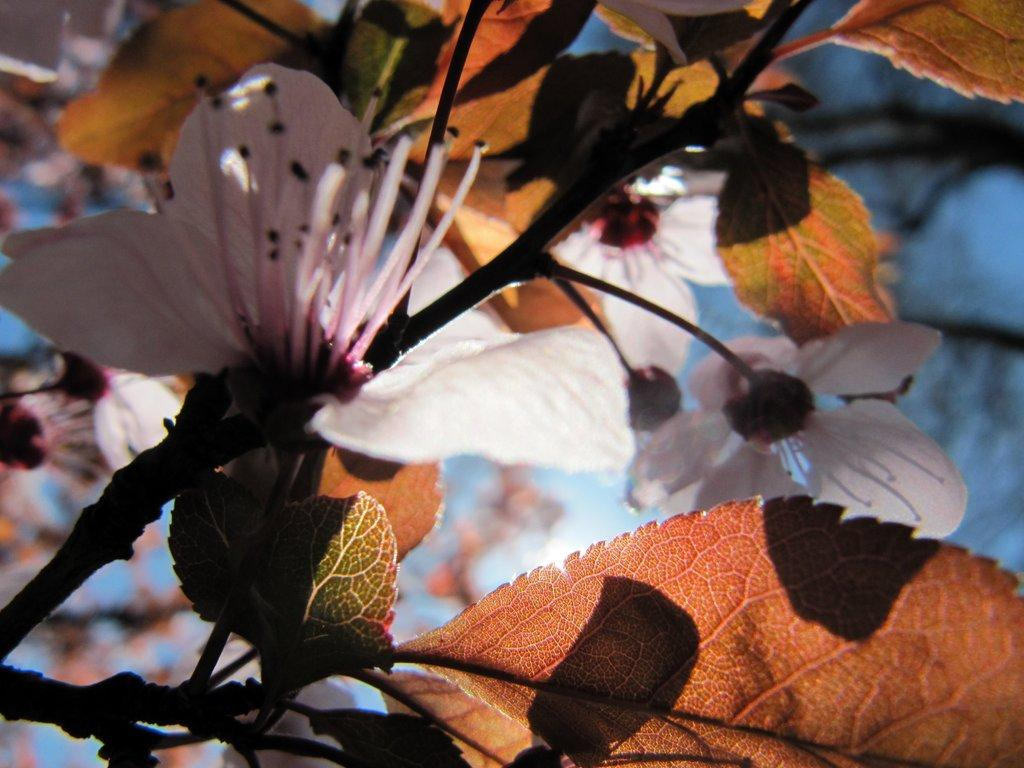What color are the flowers in the image? The flowers in the image are white-colored. What other type of plant material can be seen in the image? There are brown-colored leaves in the image. What country is depicted in the image? There is no country depicted in the image; it features white-colored flowers and brown-colored leaves. How long does it take for the string to grow in the image? There is no string present in the image, so it is not possible to determine how long it would take to grow. 